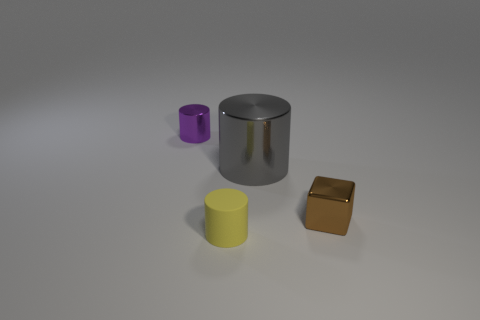Add 3 purple cylinders. How many objects exist? 7 Subtract all blue blocks. Subtract all yellow balls. How many blocks are left? 1 Subtract all cubes. How many objects are left? 3 Subtract all gray balls. Subtract all small purple shiny objects. How many objects are left? 3 Add 4 tiny metallic blocks. How many tiny metallic blocks are left? 5 Add 2 spheres. How many spheres exist? 2 Subtract 0 green cylinders. How many objects are left? 4 